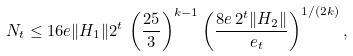Convert formula to latex. <formula><loc_0><loc_0><loc_500><loc_500>N _ { t } \leq 1 6 e \| H _ { 1 } \| 2 ^ { t } \, \left ( \frac { 2 5 } 3 \right ) ^ { k - 1 } \left ( \frac { 8 e \, 2 ^ { t } \| H _ { 2 } \| } { \ e _ { t } } \right ) ^ { 1 / ( 2 k ) } ,</formula> 